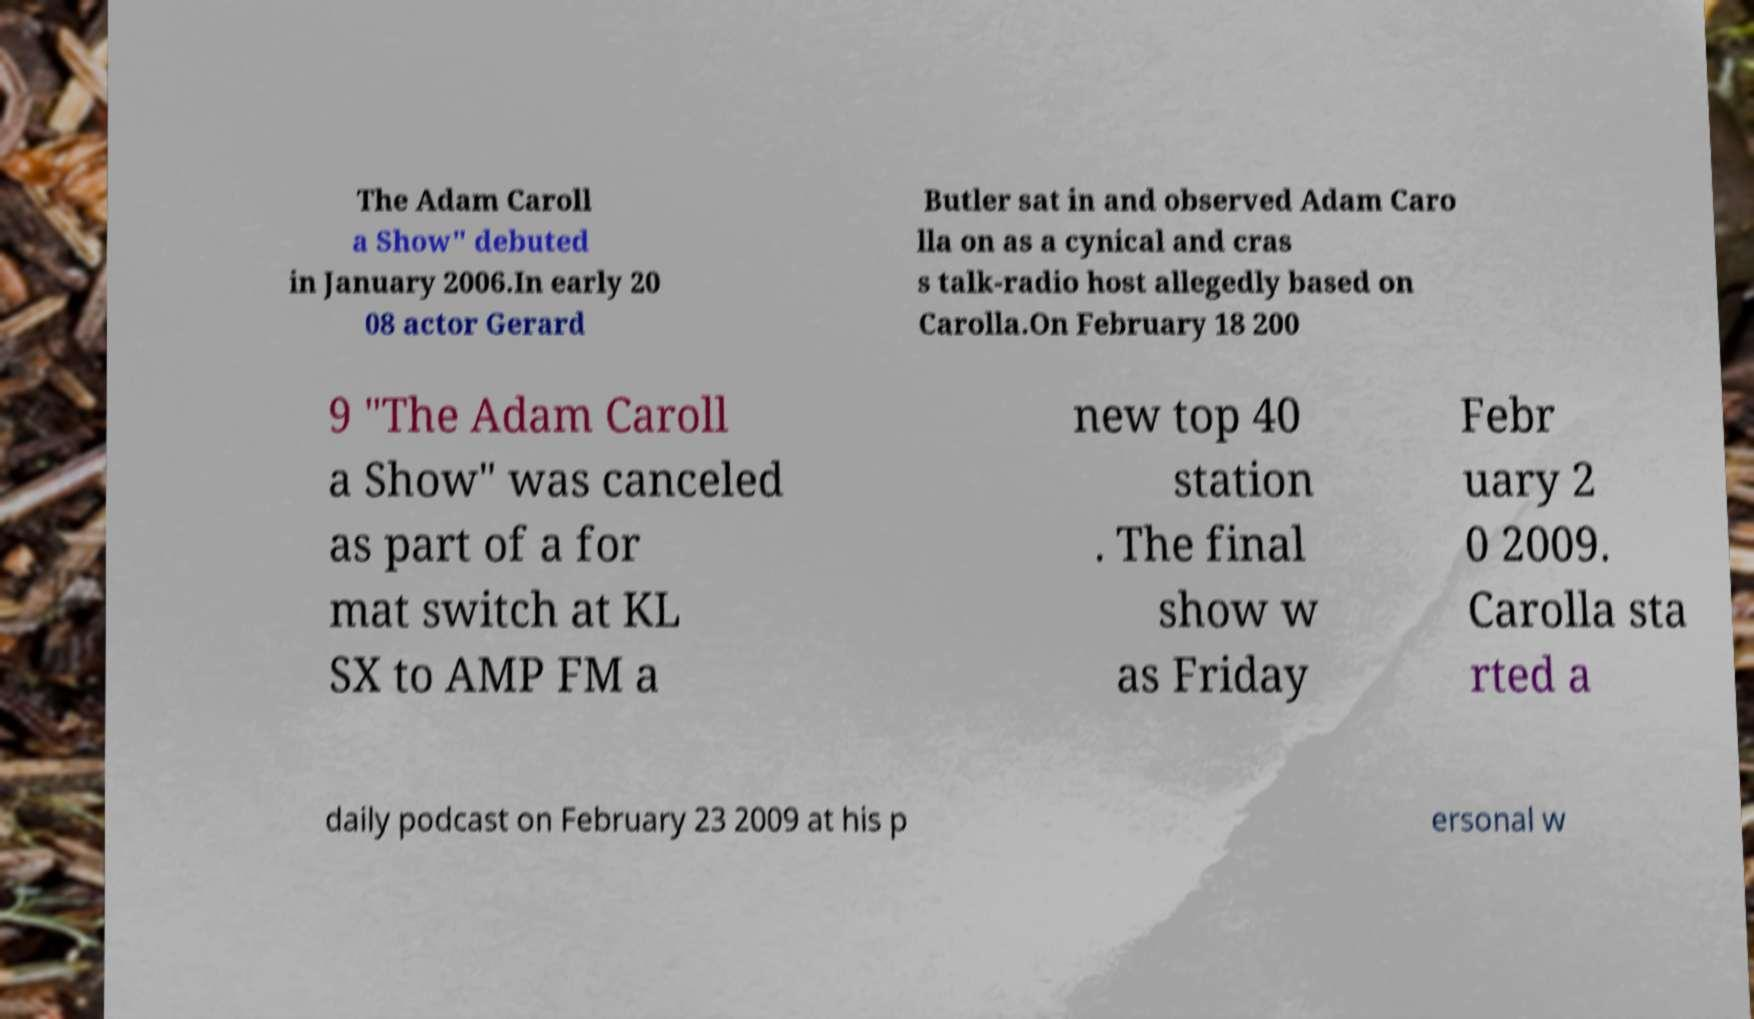Can you accurately transcribe the text from the provided image for me? The Adam Caroll a Show" debuted in January 2006.In early 20 08 actor Gerard Butler sat in and observed Adam Caro lla on as a cynical and cras s talk-radio host allegedly based on Carolla.On February 18 200 9 "The Adam Caroll a Show" was canceled as part of a for mat switch at KL SX to AMP FM a new top 40 station . The final show w as Friday Febr uary 2 0 2009. Carolla sta rted a daily podcast on February 23 2009 at his p ersonal w 